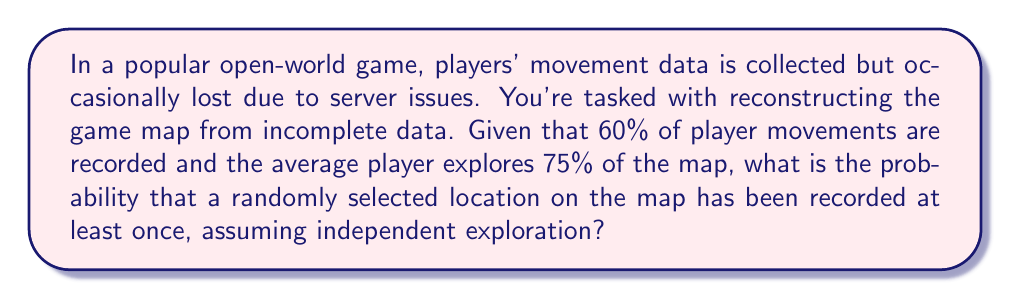Can you answer this question? Let's approach this step-by-step:

1) First, let's define our events:
   A: A randomly selected location has been explored
   B: A player's movement in an explored area is recorded

2) We're given:
   P(A) = 0.75 (75% of the map is explored on average)
   P(B|A) = 0.60 (60% of player movements are recorded)

3) We want to find P(B), the probability that a randomly selected location has been recorded.

4) We can use the law of total probability:
   P(B) = P(B|A) * P(A) + P(B|not A) * P(not A)

5) We know P(B|A) and P(A), but P(B|not A) = 0 because unexplored areas can't be recorded.

6) P(not A) = 1 - P(A) = 1 - 0.75 = 0.25

7) Now we can calculate:
   P(B) = 0.60 * 0.75 + 0 * 0.25
        = 0.45 + 0
        = 0.45

8) Therefore, the probability that a randomly selected location has been recorded is 0.45 or 45%.

This aligns with a gamer's intuition about incomplete data and map exploration, addressing potential narrative gaps in the game's world building.
Answer: 0.45 